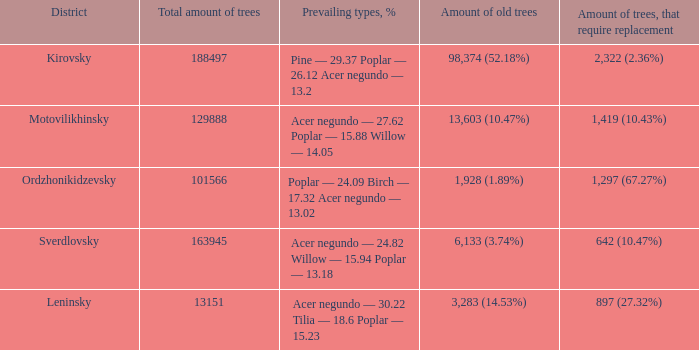What is the amount of trees, that require replacement when the district is motovilikhinsky? 1,419 (10.43%). 